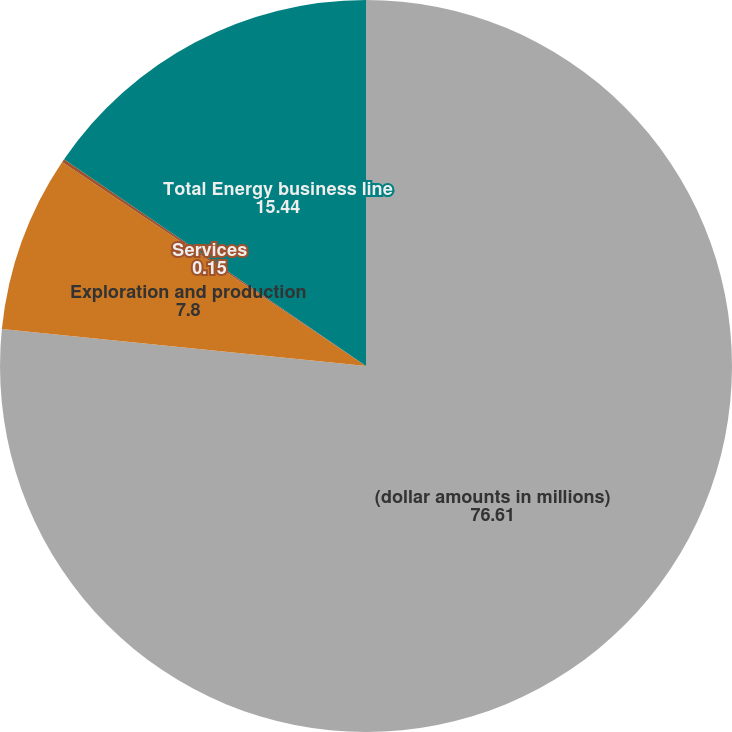Convert chart to OTSL. <chart><loc_0><loc_0><loc_500><loc_500><pie_chart><fcel>(dollar amounts in millions)<fcel>Exploration and production<fcel>Services<fcel>Total Energy business line<nl><fcel>76.61%<fcel>7.8%<fcel>0.15%<fcel>15.44%<nl></chart> 